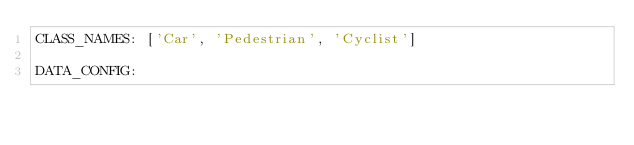Convert code to text. <code><loc_0><loc_0><loc_500><loc_500><_YAML_>CLASS_NAMES: ['Car', 'Pedestrian', 'Cyclist']

DATA_CONFIG:</code> 